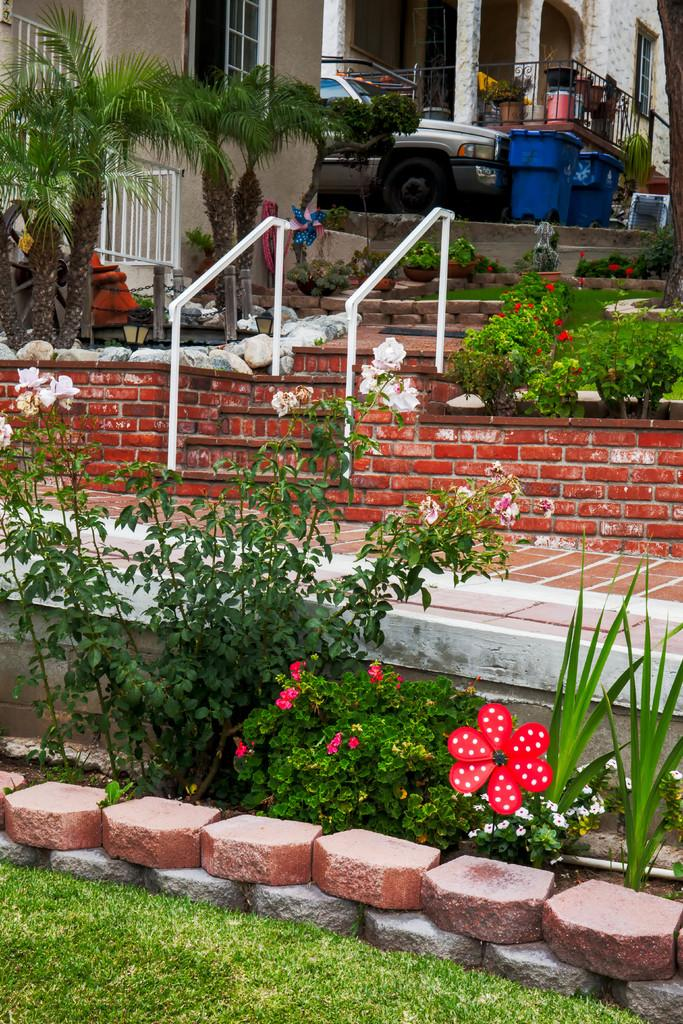What type of vegetation can be seen in the image? There is grass and plants with flowers in the image. What type of structures are visible in the image? There are buildings with windows in the image. What is located between the buildings? There is a vehicle and bins in-between the buildings. What type of barrier is present in the image? There is a fence in the image. What type of pencil can be seen supporting the buildings in the image? There is no pencil present in the image, and pencils are not capable of supporting buildings. 